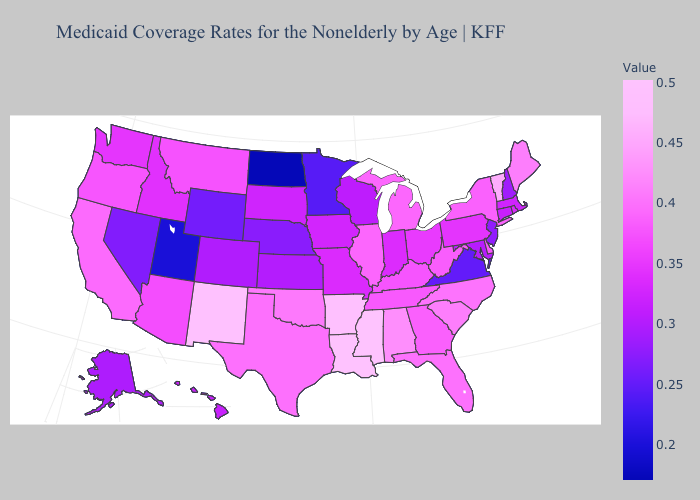Among the states that border Florida , which have the highest value?
Be succinct. Alabama. Among the states that border Michigan , does Indiana have the highest value?
Give a very brief answer. No. Among the states that border Massachusetts , does New York have the lowest value?
Write a very short answer. No. Which states hav the highest value in the MidWest?
Concise answer only. Michigan. 